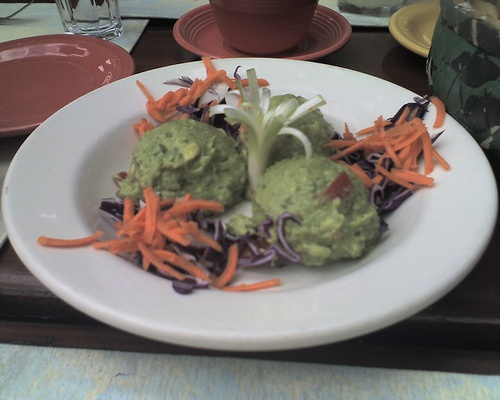Describe the objects in this image and their specific colors. I can see bowl in black, lightgray, darkgray, gray, and brown tones, broccoli in black, gray, olive, and darkgray tones, carrot in black, brown, and salmon tones, carrot in black, brown, and salmon tones, and cup in black, maroon, and brown tones in this image. 